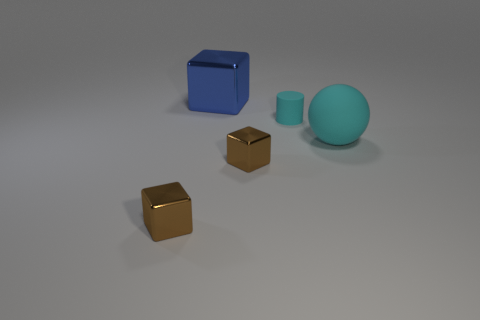There is a ball that is the same color as the tiny rubber thing; what is its material?
Ensure brevity in your answer.  Rubber. What number of tiny matte objects have the same color as the big matte ball?
Provide a succinct answer. 1. What is the large blue object made of?
Your answer should be compact. Metal. Is there any other thing of the same color as the cylinder?
Your response must be concise. Yes. There is a matte object behind the large cyan ball; does it have the same color as the ball?
Offer a very short reply. Yes. Does the blue metallic thing have the same size as the cyan cylinder?
Provide a short and direct response. No. There is a thing that is right of the blue block and behind the large cyan matte object; what is its shape?
Offer a very short reply. Cylinder. The small rubber object has what shape?
Your answer should be very brief. Cylinder. What is the shape of the matte thing that is the same color as the small matte cylinder?
Your answer should be compact. Sphere. What number of other big blue objects have the same material as the large blue object?
Give a very brief answer. 0. 